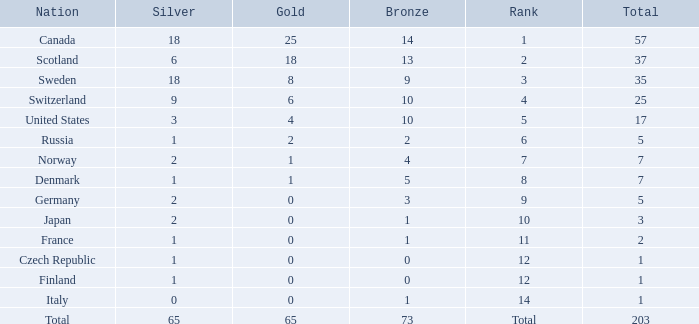What is the total number of medals when there are 18 gold medals? 37.0. 